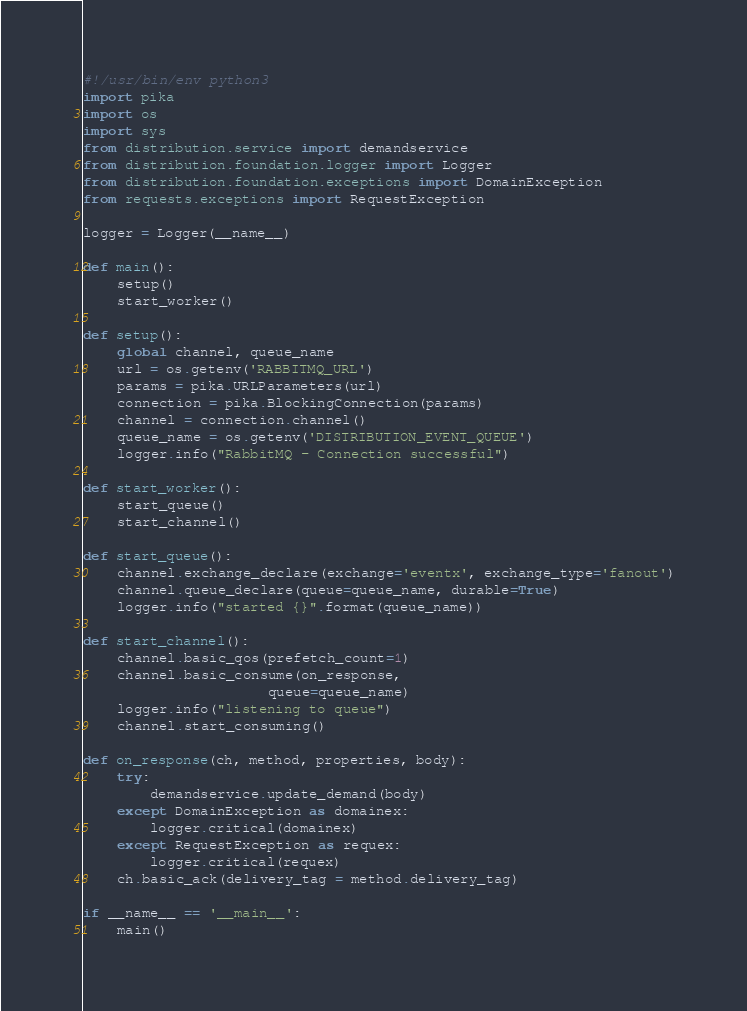<code> <loc_0><loc_0><loc_500><loc_500><_Python_>#!/usr/bin/env python3
import pika
import os
import sys
from distribution.service import demandservice
from distribution.foundation.logger import Logger
from distribution.foundation.exceptions import DomainException
from requests.exceptions import RequestException

logger = Logger(__name__)

def main():
    setup()
    start_worker()

def setup():
    global channel, queue_name
    url = os.getenv('RABBITMQ_URL')
    params = pika.URLParameters(url)
    connection = pika.BlockingConnection(params)
    channel = connection.channel()
    queue_name = os.getenv('DISTRIBUTION_EVENT_QUEUE')
    logger.info("RabbitMQ - Connection successful")

def start_worker():
    start_queue()
    start_channel()

def start_queue():
    channel.exchange_declare(exchange='eventx', exchange_type='fanout')
    channel.queue_declare(queue=queue_name, durable=True)
    logger.info("started {}".format(queue_name))

def start_channel():
    channel.basic_qos(prefetch_count=1)
    channel.basic_consume(on_response,
                      queue=queue_name)
    logger.info("listening to queue")
    channel.start_consuming()

def on_response(ch, method, properties, body):
    try:
        demandservice.update_demand(body)
    except DomainException as domainex:
        logger.critical(domainex)
    except RequestException as requex:
        logger.critical(requex)
    ch.basic_ack(delivery_tag = method.delivery_tag)

if __name__ == '__main__':
    main()</code> 